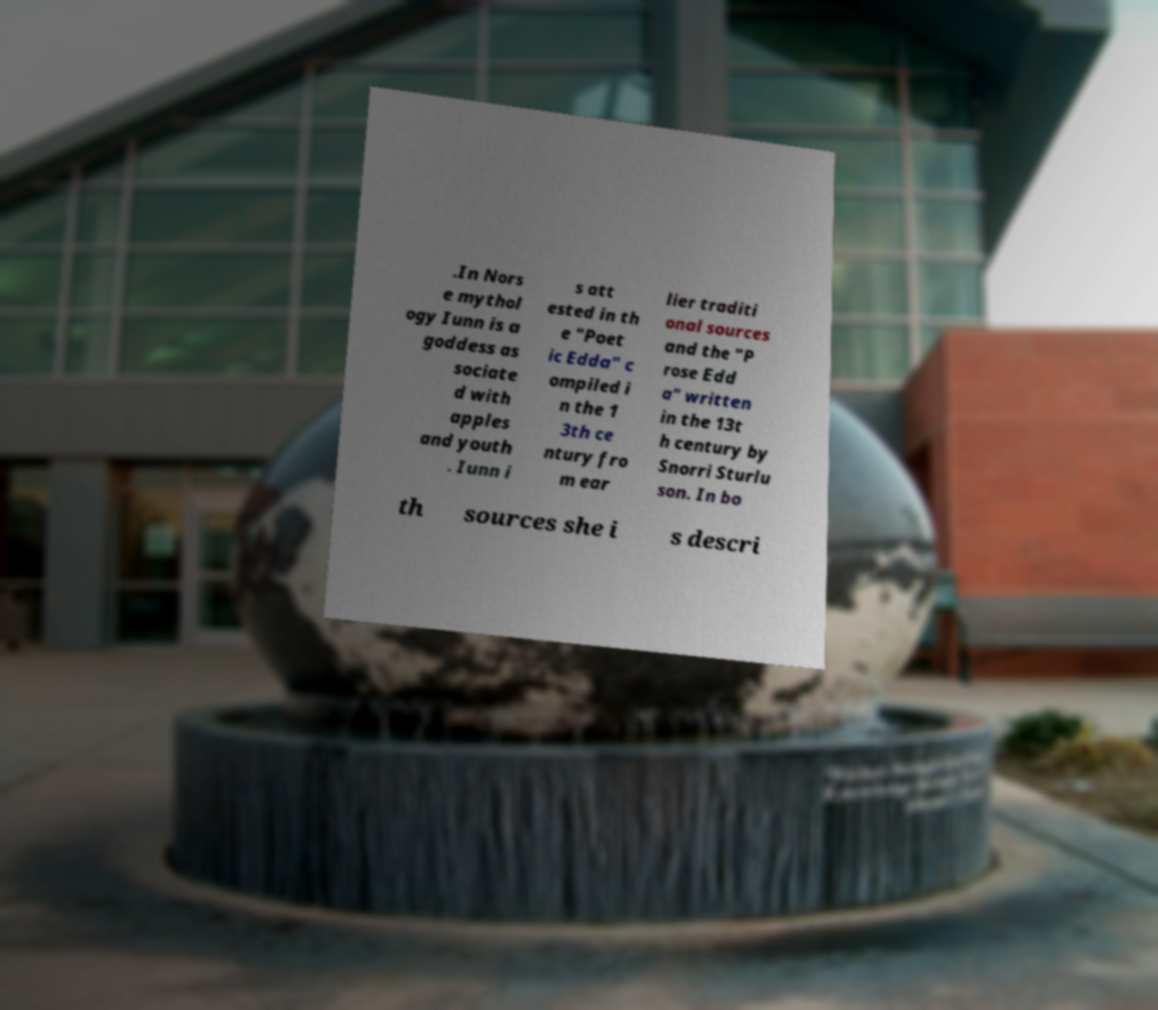Could you assist in decoding the text presented in this image and type it out clearly? .In Nors e mythol ogy Iunn is a goddess as sociate d with apples and youth . Iunn i s att ested in th e "Poet ic Edda" c ompiled i n the 1 3th ce ntury fro m ear lier traditi onal sources and the "P rose Edd a" written in the 13t h century by Snorri Sturlu son. In bo th sources she i s descri 